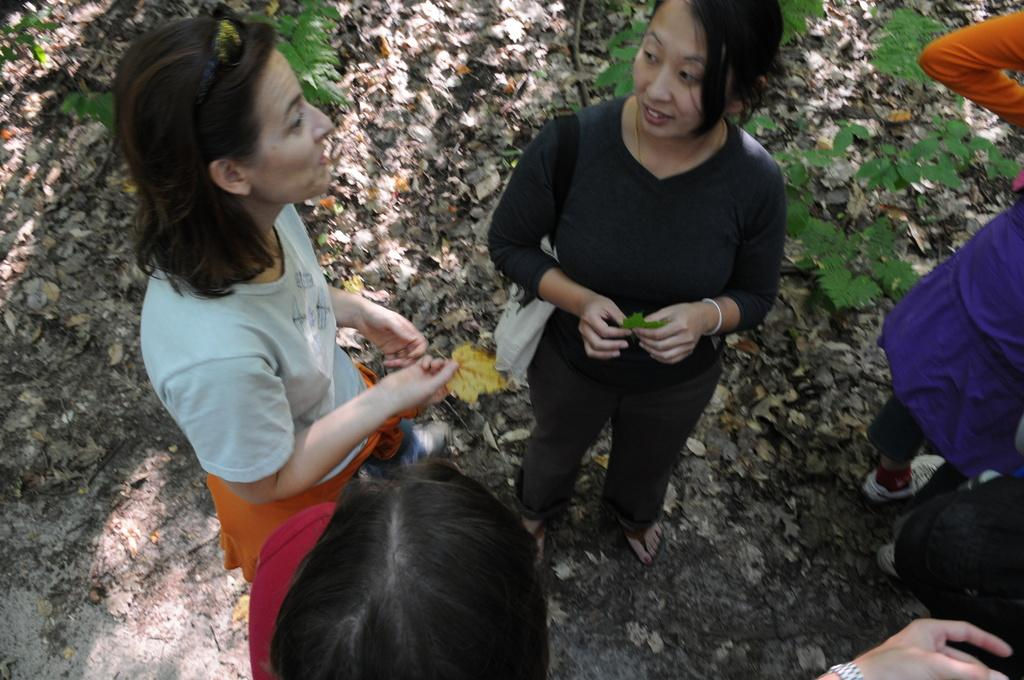How many people are standing in the center of the image? There are three people standing in the center of the image. Are there any other people visible in the image? Yes, there are people on the right side of the image. What can be seen in the background of the image? Plants are visible in the background of the image. Is there a cave visible in the image? No, there is no cave present in the image. Are any of the people attacking each other in the image? No, there is no indication of any attack or conflict in the image. 